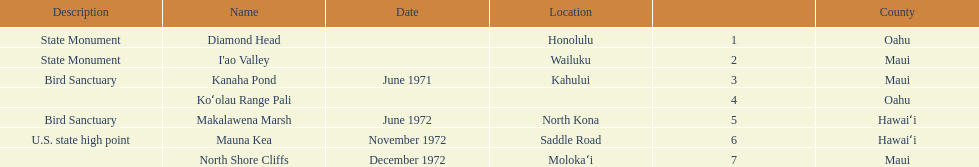Help me parse the entirety of this table. {'header': ['Description', 'Name', 'Date', 'Location', '', 'County'], 'rows': [['State Monument', 'Diamond Head', '', 'Honolulu', '1', 'Oahu'], ['State Monument', "I'ao Valley", '', 'Wailuku', '2', 'Maui'], ['Bird Sanctuary', 'Kanaha Pond', 'June 1971', 'Kahului', '3', 'Maui'], ['', 'Koʻolau Range Pali', '', '', '4', 'Oahu'], ['Bird Sanctuary', 'Makalawena Marsh', 'June 1972', 'North Kona', '5', 'Hawaiʻi'], ['U.S. state high point', 'Mauna Kea', 'November 1972', 'Saddle Road', '6', 'Hawaiʻi'], ['', 'North Shore Cliffs', 'December 1972', 'Molokaʻi', '7', 'Maui']]} Which county is featured the most on the chart? Maui. 